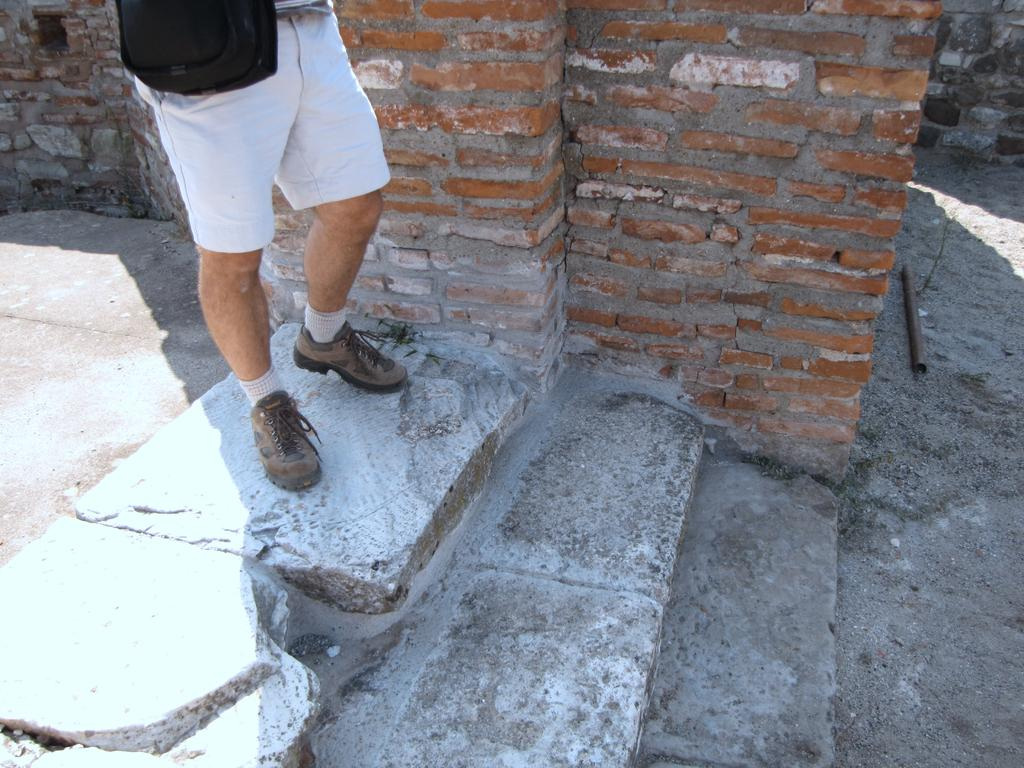What is the main subject of the image? There is a person standing in the image. Can you describe the person's attire? The person is wearing clothes, socks, and shoes. What type of background can be seen in the image? There is a brick wall, stairs, a pole, and a footpath in the image. Where is the faucet located in the image? There is no faucet present in the image. Can you describe the feather that is attached to the pole in the image? There is no feather attached to the pole in the image. 